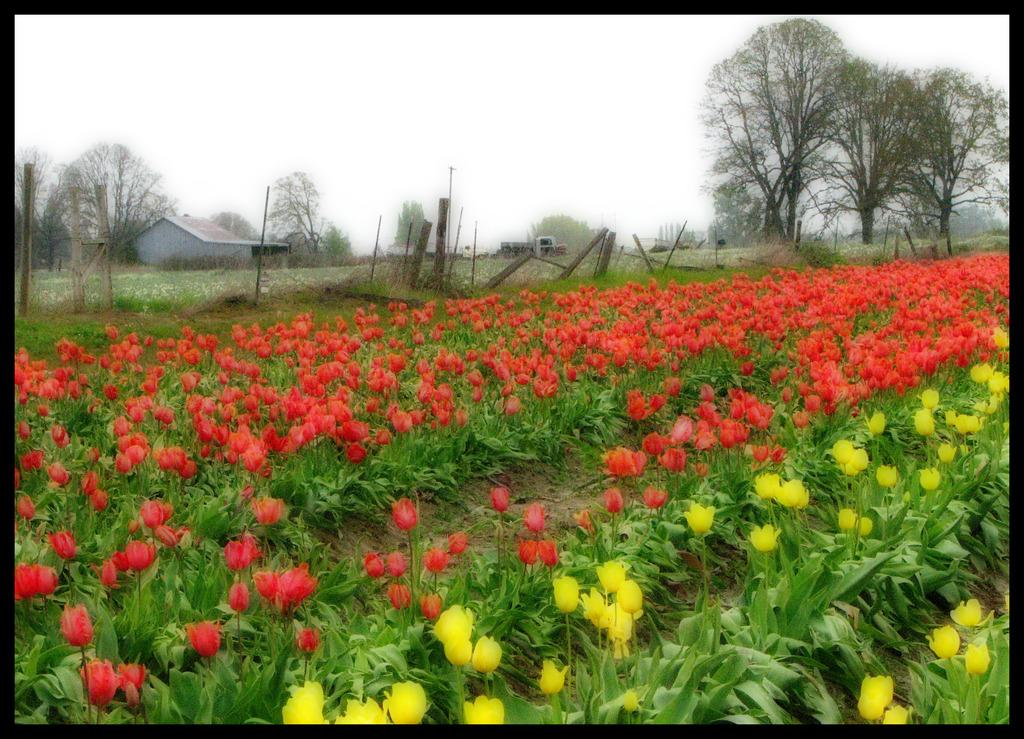What type of flowers can be seen in the image? There are red and yellow tulip flower plants in the image. How are the flower plants arranged in the image? The flower plants are spread across the land. What can be seen in the background of the image? There is a home in the background of the image. What type of vegetation is present near the home? Trees are present on either side of the home. What is visible above the home in the image? The sky is visible above the home. Can you touch the page of the book that is open in the image? There is no book present in the image, so it is not possible to touch a page. 